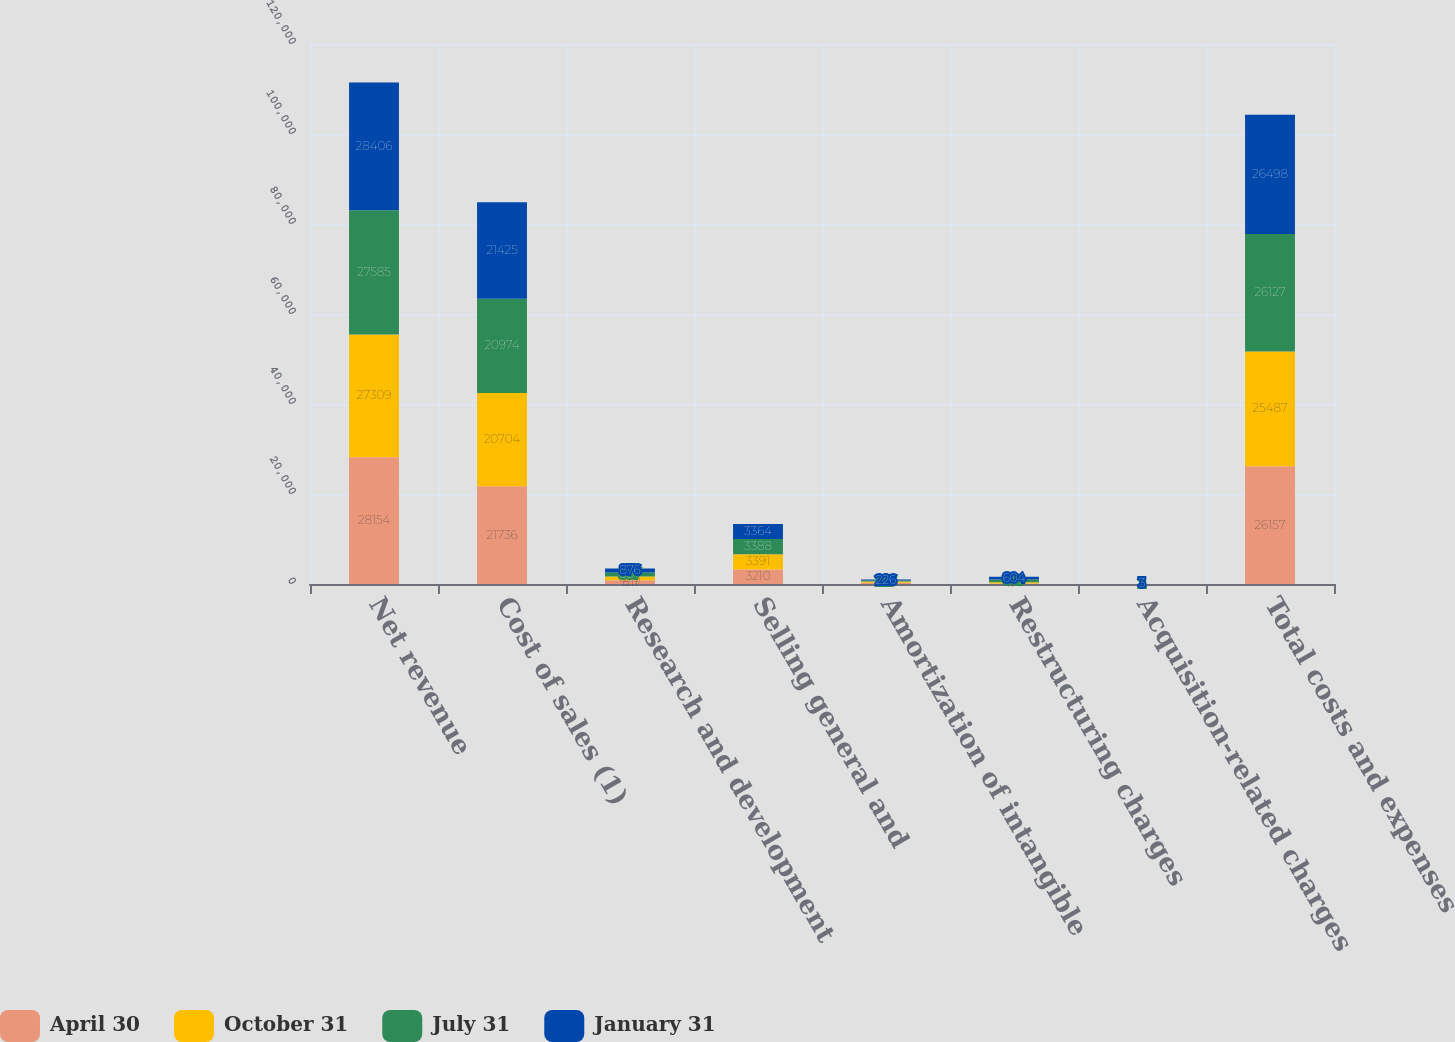Convert chart. <chart><loc_0><loc_0><loc_500><loc_500><stacked_bar_chart><ecel><fcel>Net revenue<fcel>Cost of sales (1)<fcel>Research and development<fcel>Selling general and<fcel>Amortization of intangible<fcel>Restructuring charges<fcel>Acquisition-related charges<fcel>Total costs and expenses<nl><fcel>April 30<fcel>28154<fcel>21736<fcel>811<fcel>3210<fcel>283<fcel>114<fcel>3<fcel>26157<nl><fcel>October 31<fcel>27309<fcel>20704<fcel>873<fcel>3391<fcel>264<fcel>252<fcel>3<fcel>25487<nl><fcel>July 31<fcel>27585<fcel>20974<fcel>887<fcel>3388<fcel>227<fcel>649<fcel>2<fcel>26127<nl><fcel>January 31<fcel>28406<fcel>21425<fcel>876<fcel>3364<fcel>226<fcel>604<fcel>3<fcel>26498<nl></chart> 